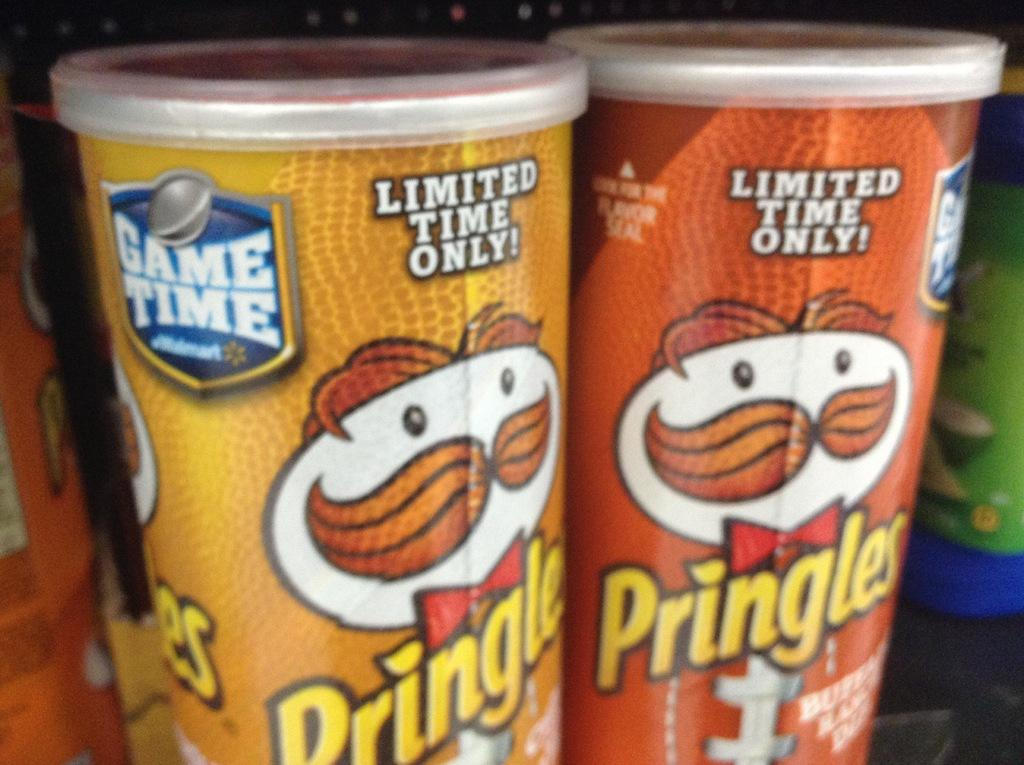<image>
Offer a succinct explanation of the picture presented. two different colored pringles cans, one is yellow, one brown 